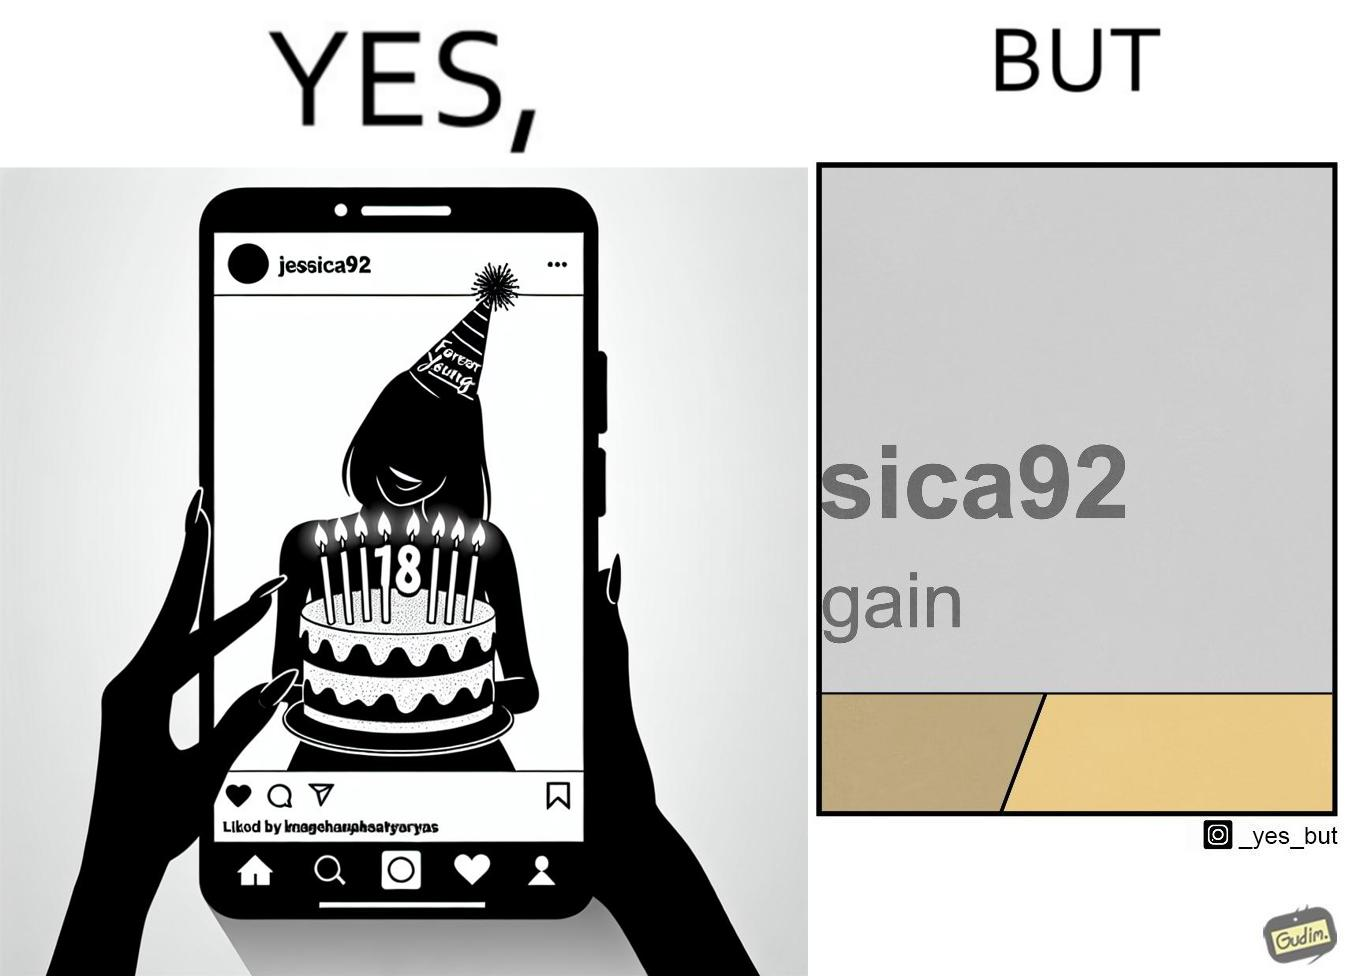What is shown in this image? The image is funny because while the woman claims she to be young, the likely year of her birth 1992 which can be inferred from her handle "jessica92" suggests that she is very old. 